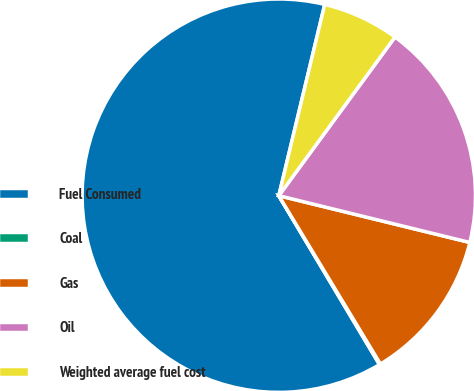Convert chart. <chart><loc_0><loc_0><loc_500><loc_500><pie_chart><fcel>Fuel Consumed<fcel>Coal<fcel>Gas<fcel>Oil<fcel>Weighted average fuel cost<nl><fcel>62.3%<fcel>0.09%<fcel>12.53%<fcel>18.76%<fcel>6.31%<nl></chart> 